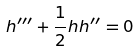Convert formula to latex. <formula><loc_0><loc_0><loc_500><loc_500>h ^ { \prime \prime \prime } + \frac { 1 } { 2 } h h ^ { \prime \prime } = 0</formula> 